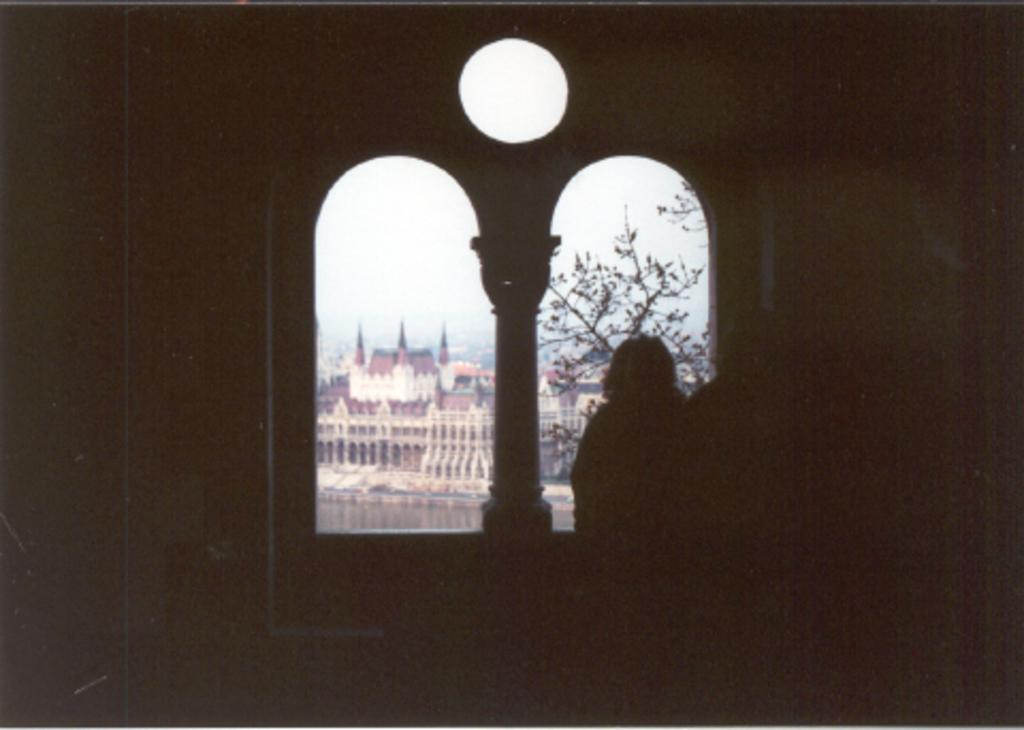What is the main subject in the image? There is a person standing in the image. What can be seen in the background of the image? There is a window in the image, and through it, buildings and a tree are visible. What type of behavior can be observed from the star in the image? There is no star present in the image, so it is not possible to observe any behavior from it. 